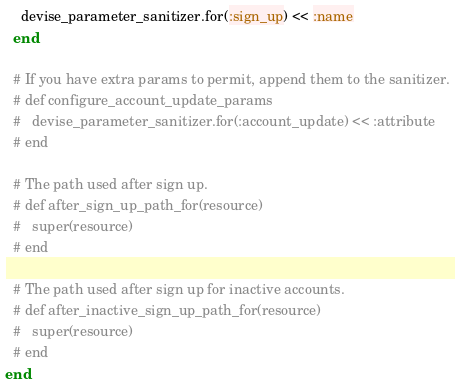<code> <loc_0><loc_0><loc_500><loc_500><_Ruby_>    devise_parameter_sanitizer.for(:sign_up) << :name
  end

  # If you have extra params to permit, append them to the sanitizer.
  # def configure_account_update_params
  #   devise_parameter_sanitizer.for(:account_update) << :attribute
  # end

  # The path used after sign up.
  # def after_sign_up_path_for(resource)
  #   super(resource)
  # end

  # The path used after sign up for inactive accounts.
  # def after_inactive_sign_up_path_for(resource)
  #   super(resource)
  # end
end
</code> 